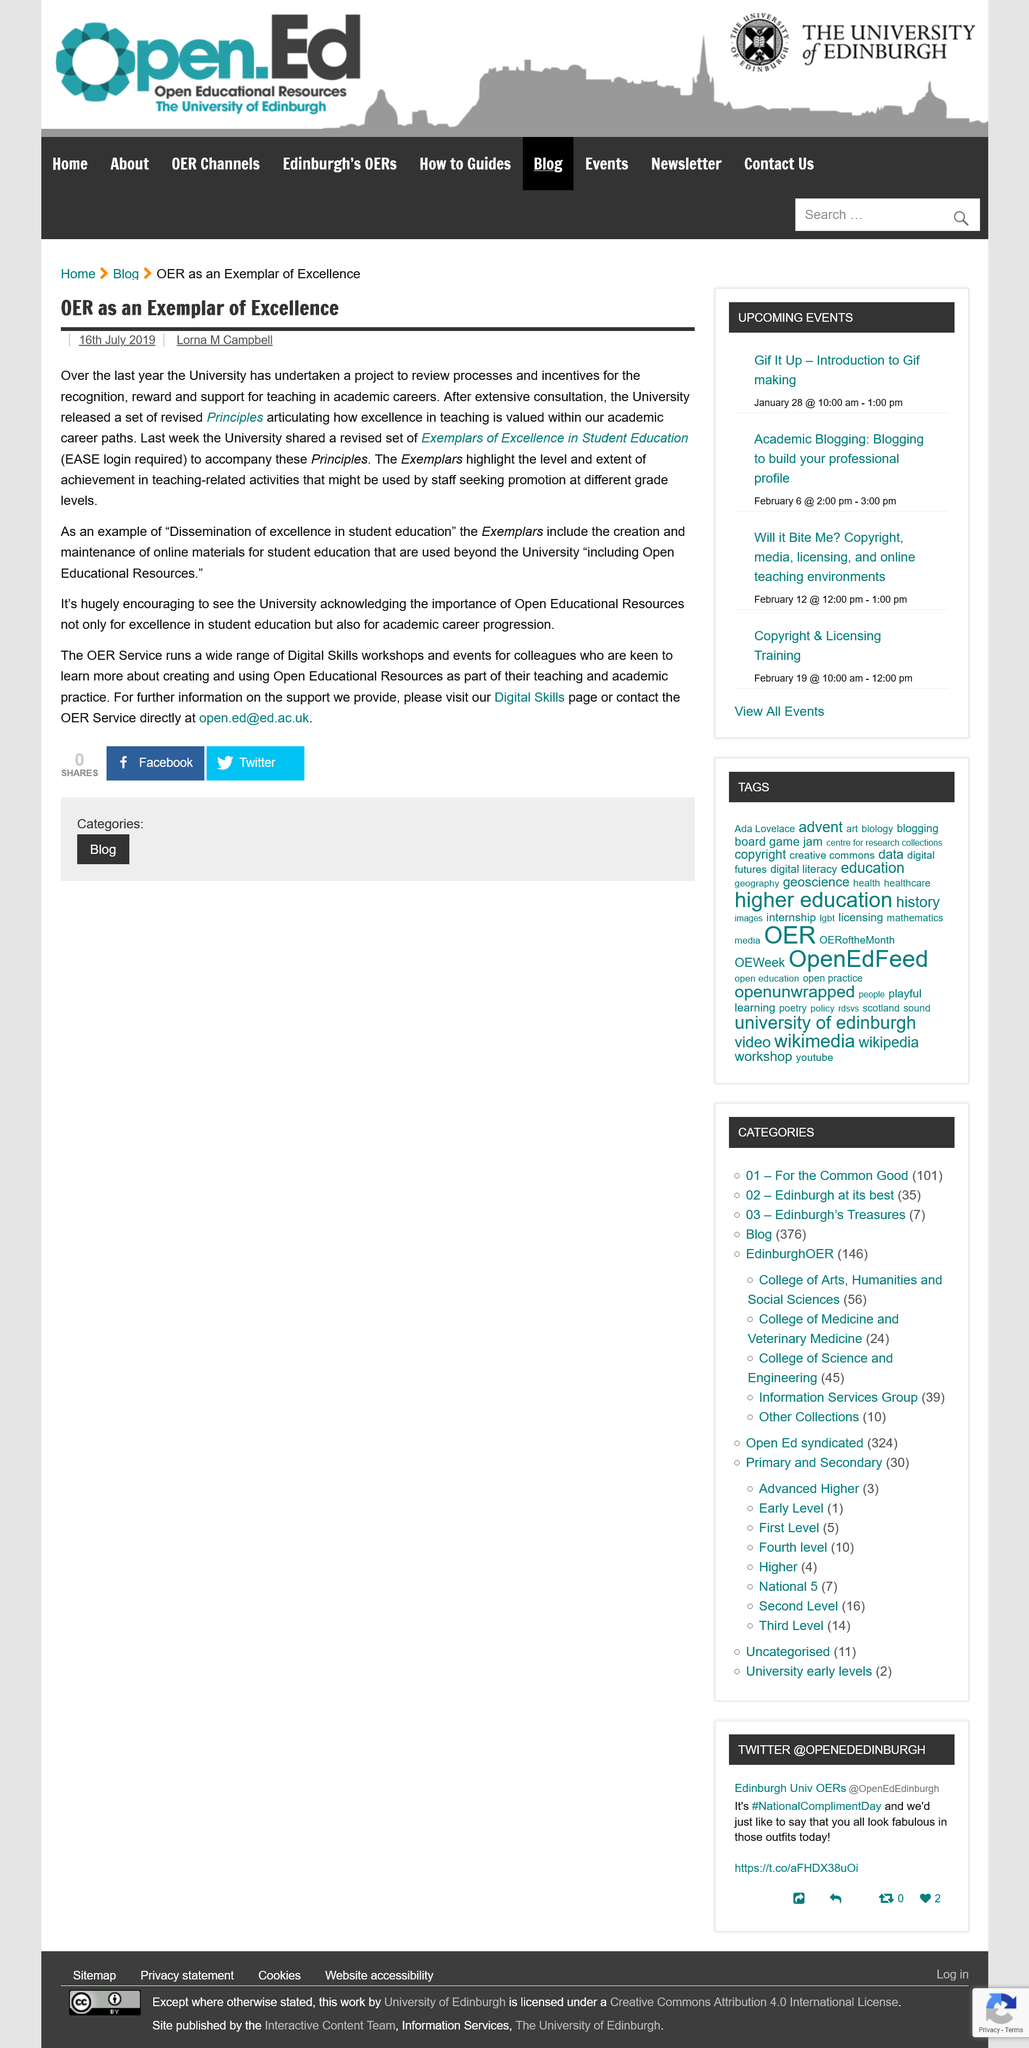Give some essential details in this illustration. The University recognizes the significance of Open Educational Resources. A login is required to access the Exemplars of Excellence in Student Education. 